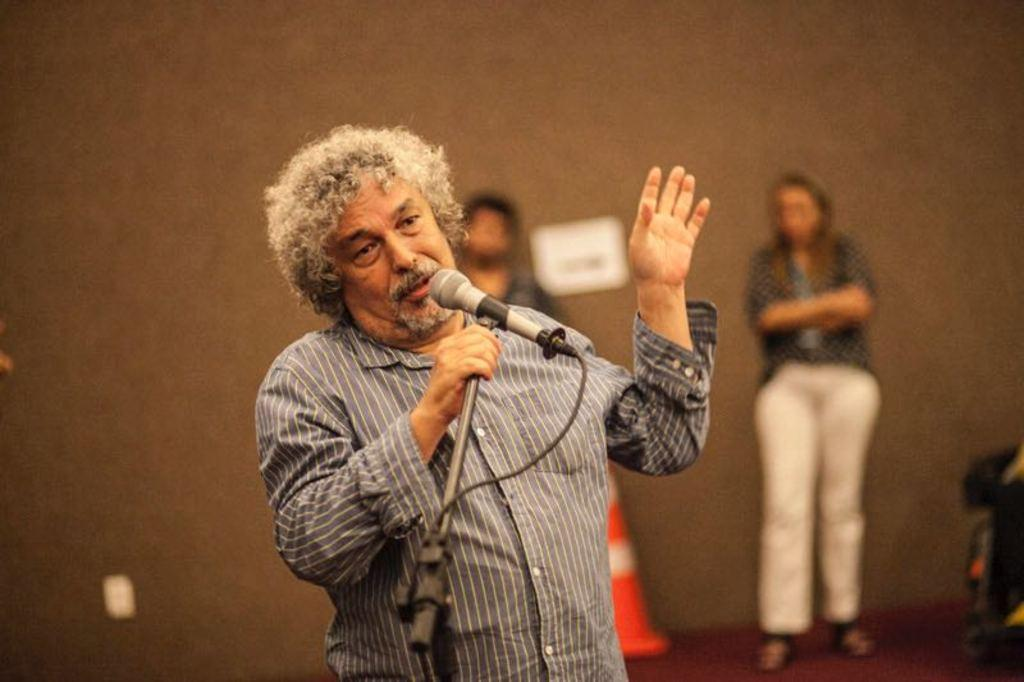What is the man in the foreground of the image holding? The man is holding a mic stand in the foreground of the image. What can be seen in the background of the image? There are two persons standing and a traffic cone present in the background of the image. What is the wall visible in the background of the image made of? The facts provided do not specify the material of the wall, so we cannot definitively answer that question. How many people are visible in the image? There is one man in the foreground and two persons in the background, making a total of three people visible in the image. What type of finger food is being served to the family in the image? There is no family present in the image, nor is there any food visible. 